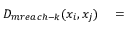Convert formula to latex. <formula><loc_0><loc_0><loc_500><loc_500>\begin{array} { r l } { D _ { m r e a c h - k } ( x _ { i } , x _ { j } ) } & = } \end{array}</formula> 